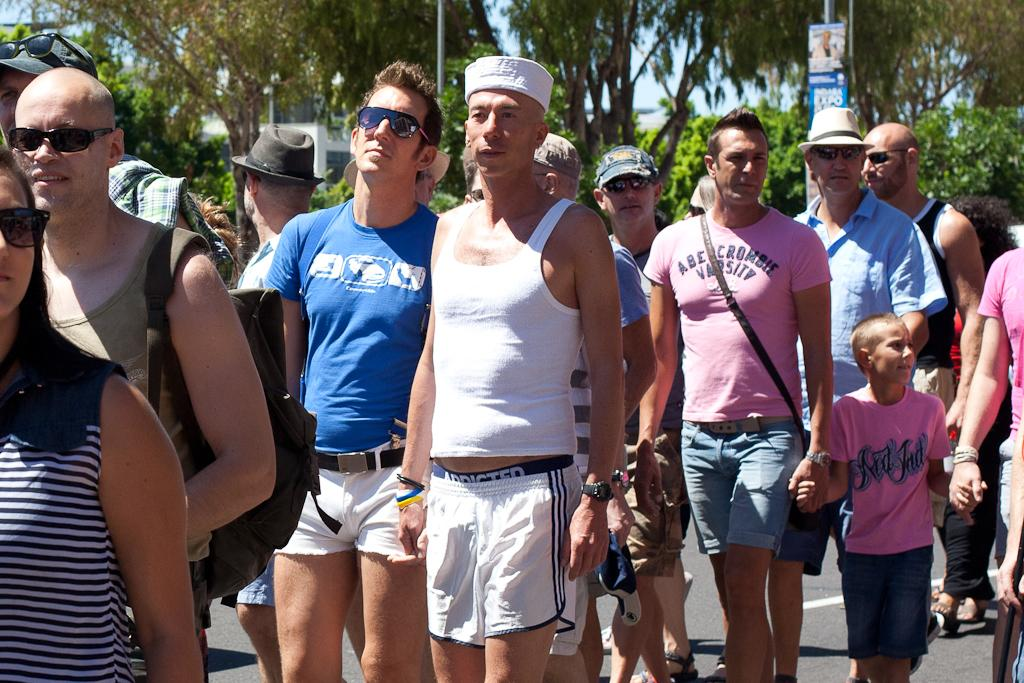<image>
Create a compact narrative representing the image presented. A man in a pink Abercrombie Varsity shirt holds hands with a little boy in a pink shirt. 